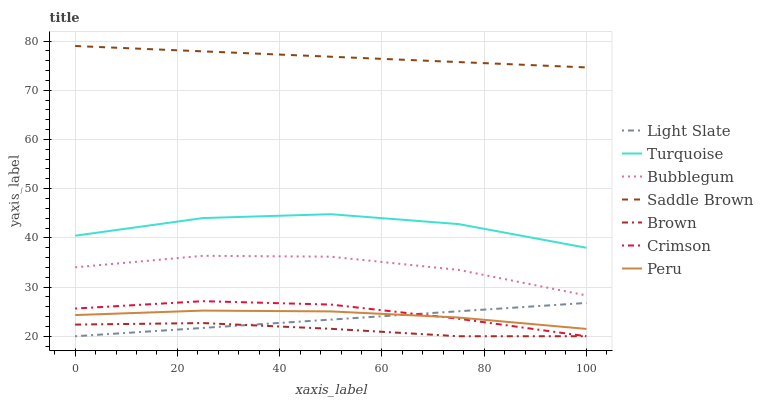Does Brown have the minimum area under the curve?
Answer yes or no. Yes. Does Saddle Brown have the maximum area under the curve?
Answer yes or no. Yes. Does Turquoise have the minimum area under the curve?
Answer yes or no. No. Does Turquoise have the maximum area under the curve?
Answer yes or no. No. Is Light Slate the smoothest?
Answer yes or no. Yes. Is Turquoise the roughest?
Answer yes or no. Yes. Is Turquoise the smoothest?
Answer yes or no. No. Is Light Slate the roughest?
Answer yes or no. No. Does Brown have the lowest value?
Answer yes or no. Yes. Does Turquoise have the lowest value?
Answer yes or no. No. Does Saddle Brown have the highest value?
Answer yes or no. Yes. Does Turquoise have the highest value?
Answer yes or no. No. Is Light Slate less than Bubblegum?
Answer yes or no. Yes. Is Saddle Brown greater than Crimson?
Answer yes or no. Yes. Does Crimson intersect Light Slate?
Answer yes or no. Yes. Is Crimson less than Light Slate?
Answer yes or no. No. Is Crimson greater than Light Slate?
Answer yes or no. No. Does Light Slate intersect Bubblegum?
Answer yes or no. No. 